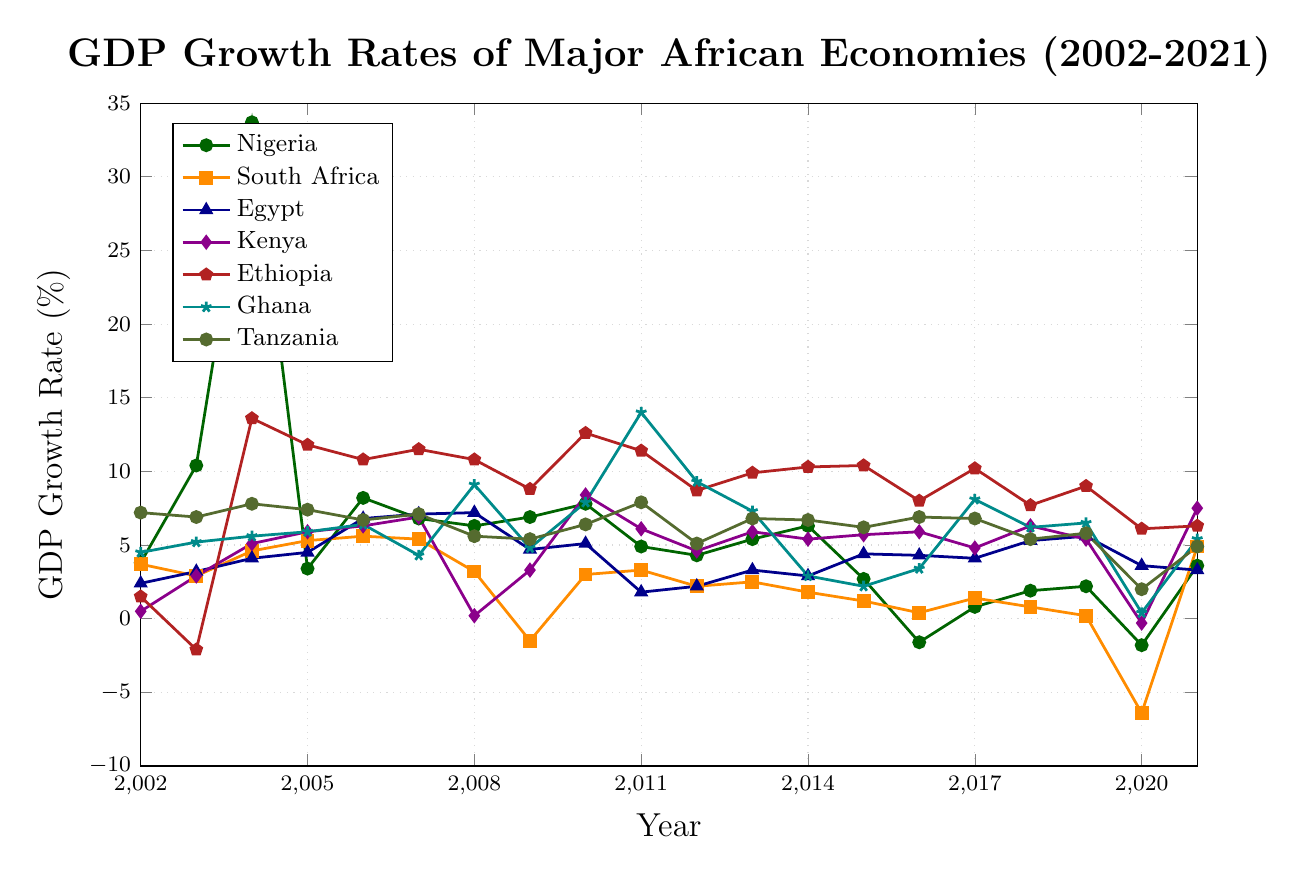Which major African economy had the highest GDP growth rate in 2004? Look for the highest point in the year 2004 on the chart. Nigeria has the highest GDP growth rate.
Answer: Nigeria During which year did South Africa experience its lowest GDP growth rate, and what was the rate? Identify the lowest point on the South Africa line. The lowest rate is in 2020.
Answer: 2020, -6.4% What was the average GDP growth rate for Kenya between 2010 and 2015? Calculate the average of Kenya’s GDP growth rates for the years 2010-2015 (8.4, 6.1, 4.6, 5.9, 5.4, 5.7). The average is (8.4 + 6.1 + 4.6 + 5.9 + 5.4 + 5.7) / 6.
Answer: 6.02% In which years did Nigeria have a negative GDP growth rate? Find the years where the line for Nigeria falls below 0. It happens in 2016 and 2020.
Answer: 2016, 2020 Did Ethiopia ever experience negative GDP growth, and if so, in which year? Look for negative values on Ethiopia's line. Ethiopia experienced negative growth in 2003.
Answer: 2003 How did Tanzania’s GDP growth rate in 2006 compare to that in 2016? Compare the values for Tanzania in 2006 and 2016. Both years have the same GDP growth rate of 6.9%.
Answer: Equal What was the trend in Egypt’s GDP growth rate from 2018 to 2021? Look at the line for Egypt from 2018 to 2021. It went from 5.3% in 2018 to 5.6% in 2019, down to 3.6% in 2020, and to 3.3% in 2021, indicating a decreasing trend.
Answer: Decreasing What is the difference between Ghana’s GDP growth rates in 2011 and 2012? Find Ghana's GDP growth rates in 2011 (14.0%) and 2012 (9.3%) and calculate the difference. 14.0% - 9.3% = 4.7%.
Answer: 4.7% Which economy had the most fluctuating GDP growth rate throughout the 20 years, and what is one evidence of this fluctuation? Look for the country with the most dramatic changes in GDP growth rate. Nigeria has large fluctuations, evidenced by a peak at 33.7% in 2004 and drops to negative values in later years.
Answer: Nigeria, evidence is peak at 33.7% in 2004 and negative in 2016, 2020 